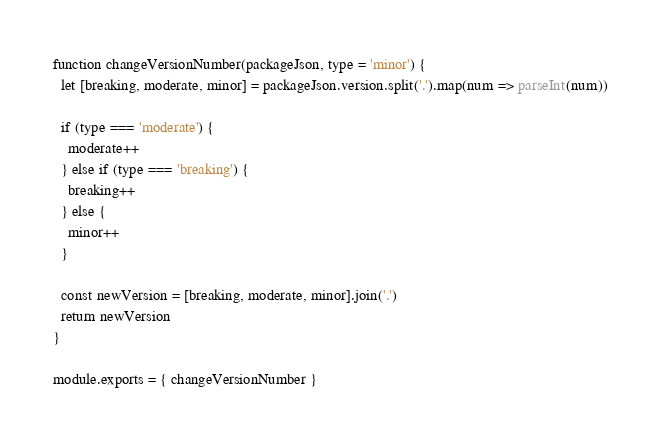<code> <loc_0><loc_0><loc_500><loc_500><_JavaScript_>function changeVersionNumber(packageJson, type = 'minor') {
  let [breaking, moderate, minor] = packageJson.version.split('.').map(num => parseInt(num))

  if (type === 'moderate') {
    moderate++
  } else if (type === 'breaking') {
    breaking++
  } else {
    minor++
  }

  const newVersion = [breaking, moderate, minor].join('.')
  return newVersion
}

module.exports = { changeVersionNumber }</code> 